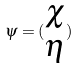<formula> <loc_0><loc_0><loc_500><loc_500>\psi = ( \begin{matrix} \chi \\ \eta \end{matrix} )</formula> 